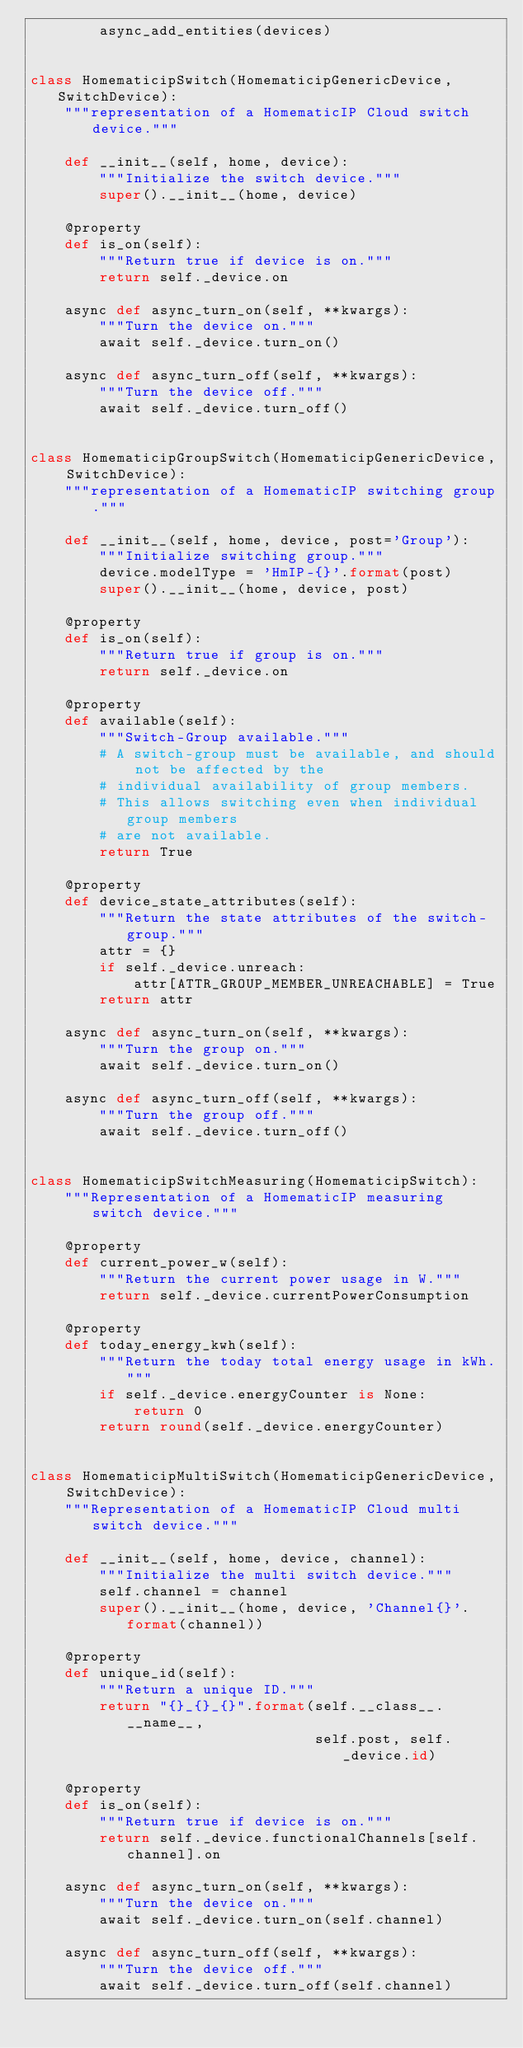<code> <loc_0><loc_0><loc_500><loc_500><_Python_>        async_add_entities(devices)


class HomematicipSwitch(HomematicipGenericDevice, SwitchDevice):
    """representation of a HomematicIP Cloud switch device."""

    def __init__(self, home, device):
        """Initialize the switch device."""
        super().__init__(home, device)

    @property
    def is_on(self):
        """Return true if device is on."""
        return self._device.on

    async def async_turn_on(self, **kwargs):
        """Turn the device on."""
        await self._device.turn_on()

    async def async_turn_off(self, **kwargs):
        """Turn the device off."""
        await self._device.turn_off()


class HomematicipGroupSwitch(HomematicipGenericDevice, SwitchDevice):
    """representation of a HomematicIP switching group."""

    def __init__(self, home, device, post='Group'):
        """Initialize switching group."""
        device.modelType = 'HmIP-{}'.format(post)
        super().__init__(home, device, post)

    @property
    def is_on(self):
        """Return true if group is on."""
        return self._device.on

    @property
    def available(self):
        """Switch-Group available."""
        # A switch-group must be available, and should not be affected by the
        # individual availability of group members.
        # This allows switching even when individual group members
        # are not available.
        return True

    @property
    def device_state_attributes(self):
        """Return the state attributes of the switch-group."""
        attr = {}
        if self._device.unreach:
            attr[ATTR_GROUP_MEMBER_UNREACHABLE] = True
        return attr

    async def async_turn_on(self, **kwargs):
        """Turn the group on."""
        await self._device.turn_on()

    async def async_turn_off(self, **kwargs):
        """Turn the group off."""
        await self._device.turn_off()


class HomematicipSwitchMeasuring(HomematicipSwitch):
    """Representation of a HomematicIP measuring switch device."""

    @property
    def current_power_w(self):
        """Return the current power usage in W."""
        return self._device.currentPowerConsumption

    @property
    def today_energy_kwh(self):
        """Return the today total energy usage in kWh."""
        if self._device.energyCounter is None:
            return 0
        return round(self._device.energyCounter)


class HomematicipMultiSwitch(HomematicipGenericDevice, SwitchDevice):
    """Representation of a HomematicIP Cloud multi switch device."""

    def __init__(self, home, device, channel):
        """Initialize the multi switch device."""
        self.channel = channel
        super().__init__(home, device, 'Channel{}'.format(channel))

    @property
    def unique_id(self):
        """Return a unique ID."""
        return "{}_{}_{}".format(self.__class__.__name__,
                                 self.post, self._device.id)

    @property
    def is_on(self):
        """Return true if device is on."""
        return self._device.functionalChannels[self.channel].on

    async def async_turn_on(self, **kwargs):
        """Turn the device on."""
        await self._device.turn_on(self.channel)

    async def async_turn_off(self, **kwargs):
        """Turn the device off."""
        await self._device.turn_off(self.channel)
</code> 